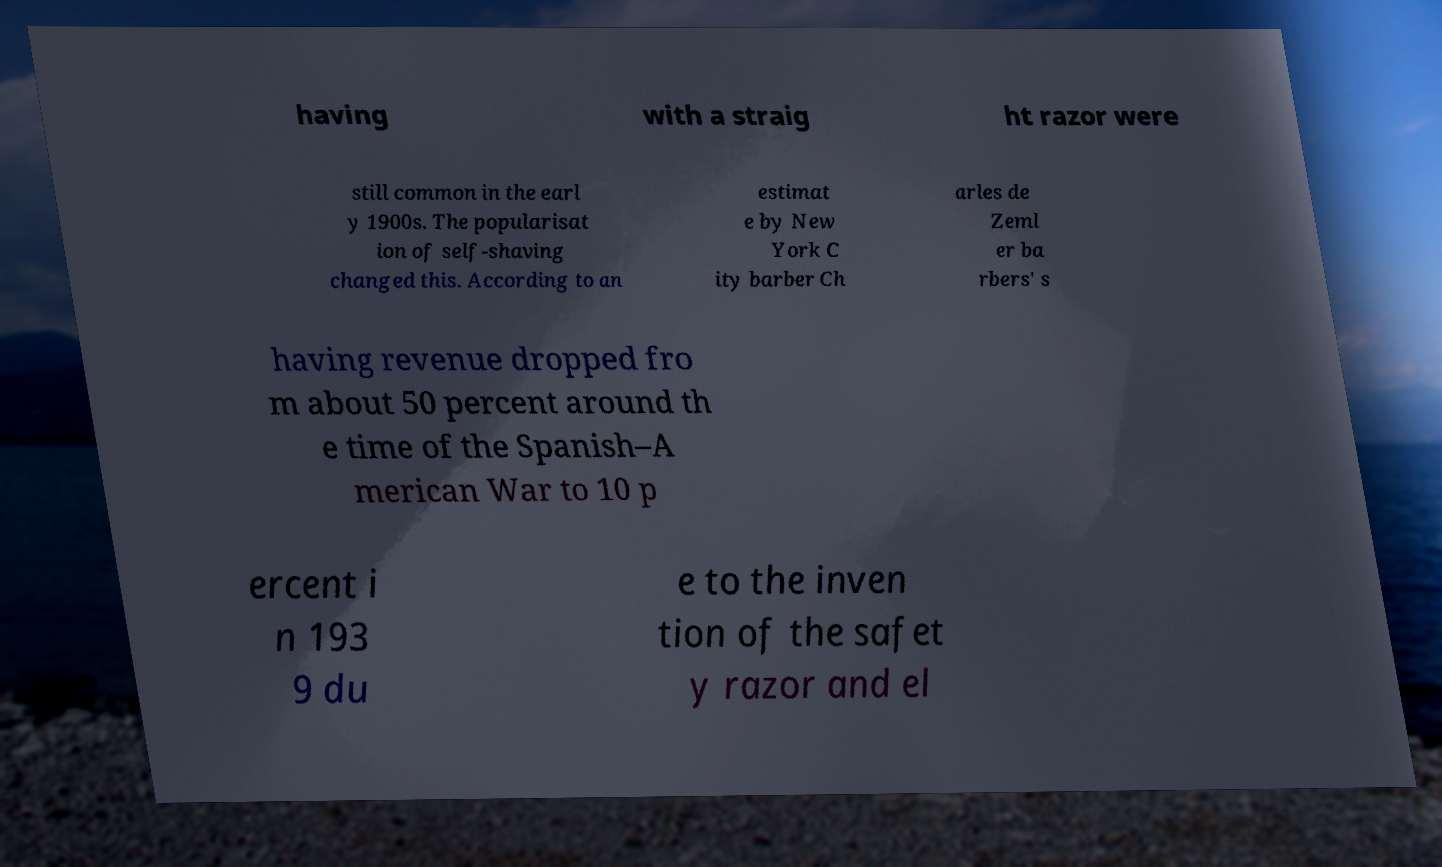Could you extract and type out the text from this image? having with a straig ht razor were still common in the earl y 1900s. The popularisat ion of self-shaving changed this. According to an estimat e by New York C ity barber Ch arles de Zeml er ba rbers' s having revenue dropped fro m about 50 percent around th e time of the Spanish–A merican War to 10 p ercent i n 193 9 du e to the inven tion of the safet y razor and el 